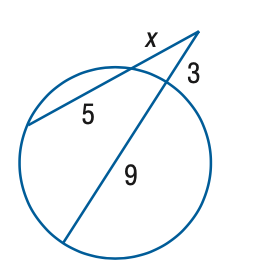Answer the mathemtical geometry problem and directly provide the correct option letter.
Question: Find x to the nearest tenth. 
Choices: A: 2 B: 3 C: 4 D: 5 C 